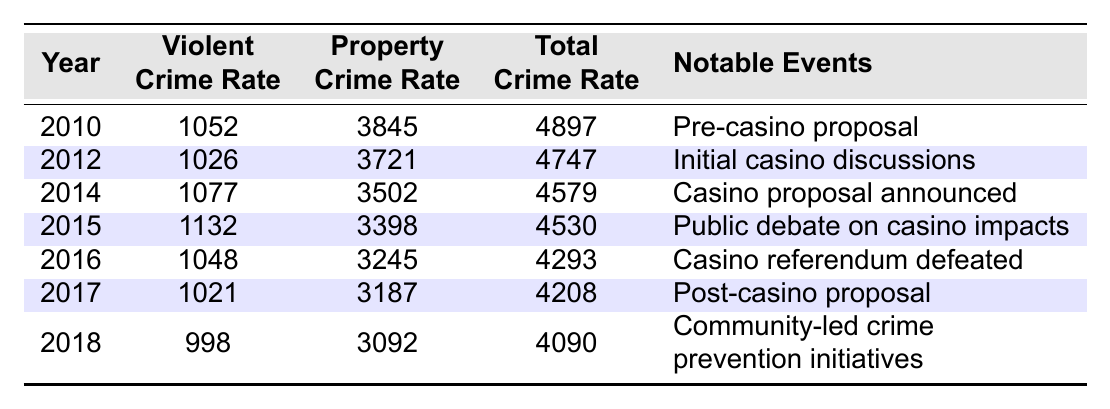What was the property crime rate in New Bedford in 2010? Referring to the table, the property crime rate for the year 2010 is listed as 3845.
Answer: 3845 What was the total crime rate in New Bedford in 2018? The table shows that the total crime rate in New Bedford for the year 2018 is 4090.
Answer: 4090 Which year experienced the highest violent crime rate? By comparing the violent crime rates from all the years, 2015 shows the highest violent crime rate at 1132.
Answer: 2015 What is the difference in the violent crime rate from 2010 to 2016? The violent crime rate in 2010 was 1052, and in 2016 it was 1048. The difference is 1052 - 1048 = 4.
Answer: 4 What is the average total crime rate from 2010 to 2018? The total crime rates are: 4897 (2010), 4747 (2012), 4579 (2014), 4530 (2015), 4293 (2016), 4208 (2017), 4090 (2018). Adding these gives 28944. Dividing by 7 (the number of years) gives an average of 4134.
Answer: 4134 Was there an increase or decrease in the property crime rate from 2014 to 2015? In 2014, the property crime rate was 3502, and in 2015 it decreased to 3398. This indicates a decrease.
Answer: Decrease How did the total crime rate in 2017 compare to the rate in 2016? The total crime rate was 4293 in 2016 and 4208 in 2017. Comparing these shows a decrease of 85.
Answer: Decrease In which year was the casino referendum defeated and what was the violent crime rate for that year? The table indicates that the casino referendum was defeated in 2016, and the violent crime rate for that year was 1048.
Answer: 1048 What notable event occurred in New Bedford in 2012? According to the table, the notable event in New Bedford in 2012 was the initial casino discussions.
Answer: Initial casino discussions Did the violent crime rate in 2018 drop lower than it was in 2010? Yes, in 2010 the violent crime rate was 1052, and in 2018 it was 998. This indicates a drop.
Answer: Yes 